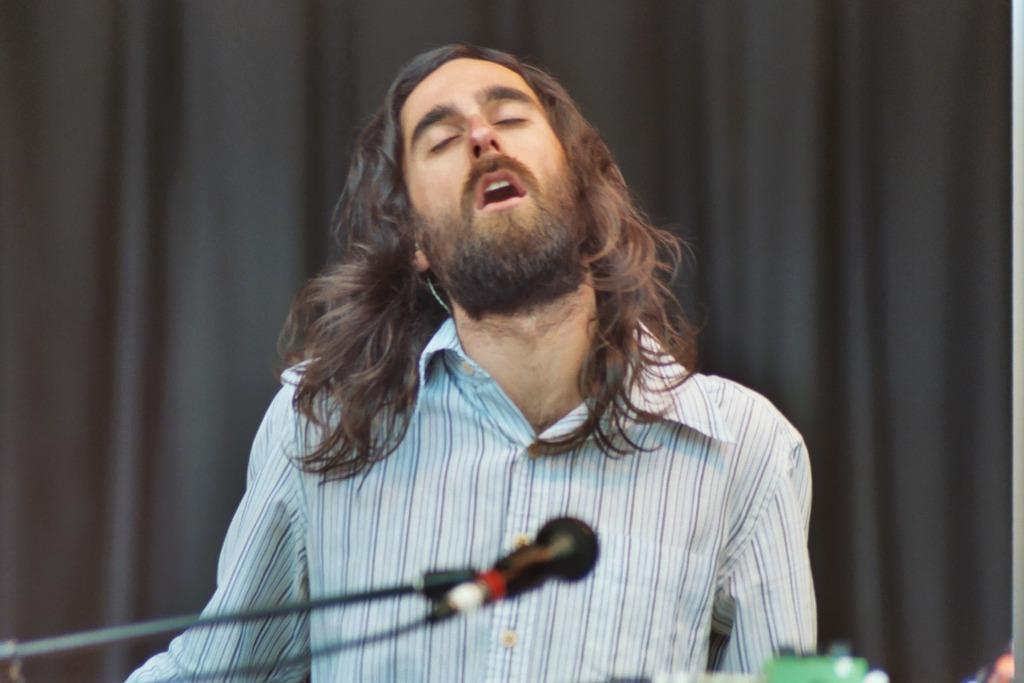What is the person in the image doing? The person in the image is singing. What object is the person using while singing? There is a microphone in the image. What can be seen in the background of the image? There is a black curtain in the background of the image. What type of brass instrument is the person playing in the image? There is no brass instrument present in the image; the person is singing with a microphone. What is the name of the person in the image? The provided facts do not include the name of the person in the image. 